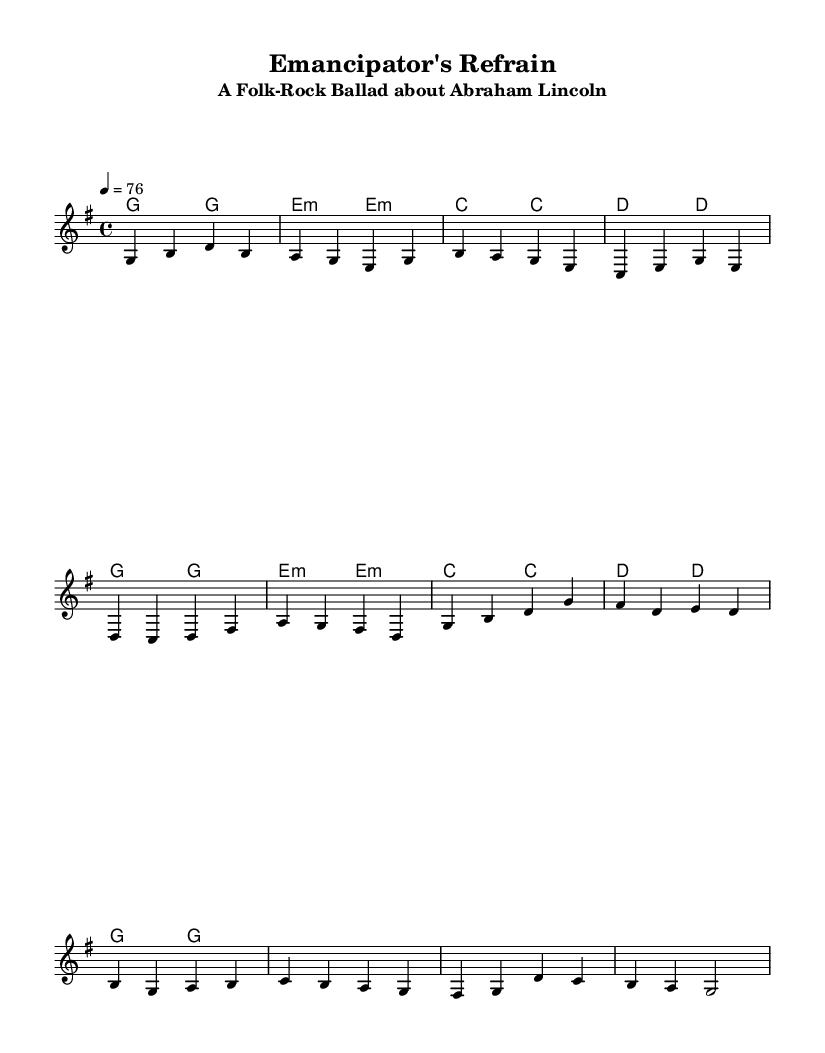What is the key signature of this music? The key signature indicated in the music is G major, which has one sharp (F#). You can identify the key signature from the beginning of the score where the key is marked.
Answer: G major What is the time signature of this music? The time signature shown in the score is 4/4, denoting four beats per measure with a quarter note receiving one beat. This is located right after the key signature at the beginning of the score.
Answer: 4/4 What is the tempo marking for this piece? The tempo marking defines the speed at which the piece should be played, which in this case is marked as 76 beats per minute. This information is found in the tempo indication at the start of the music.
Answer: 76 How many measures does the chorus section have? The chorus consists of four measures, each represented by individual groups of music notation separating the lines. You can count the measure bars to find this total.
Answer: 4 What is the primary theme of the lyrics? The lyrics focus on Abraham Lincoln's leadership and legacy, which can be inferred by analyzing the phrases and keywords throughout the verses and chorus that highlight his role as a significant historical figure.
Answer: Abraham Lincoln What type of chords are used in the chorus? The chords in the chorus include G major, E minor, C major, and D major chords, which can be recognized by looking at the chord symbols above the corresponding measures in the score. The choice of these chords gives it a folk-rock feel with both harmony and emotion.
Answer: G, E minor, C, D How do the melodies in the verses compare to the chorus? The melodies in the verses transition smoothly into the melodies in the chorus, showcasing a typical folk-rock style where themes are developed and reiterated, emphasizing the lyrical narrative of Lincoln's story. The melodic structure moves similarly but with variations in rhythm and pitch emphasis.
Answer: Smooth transition 